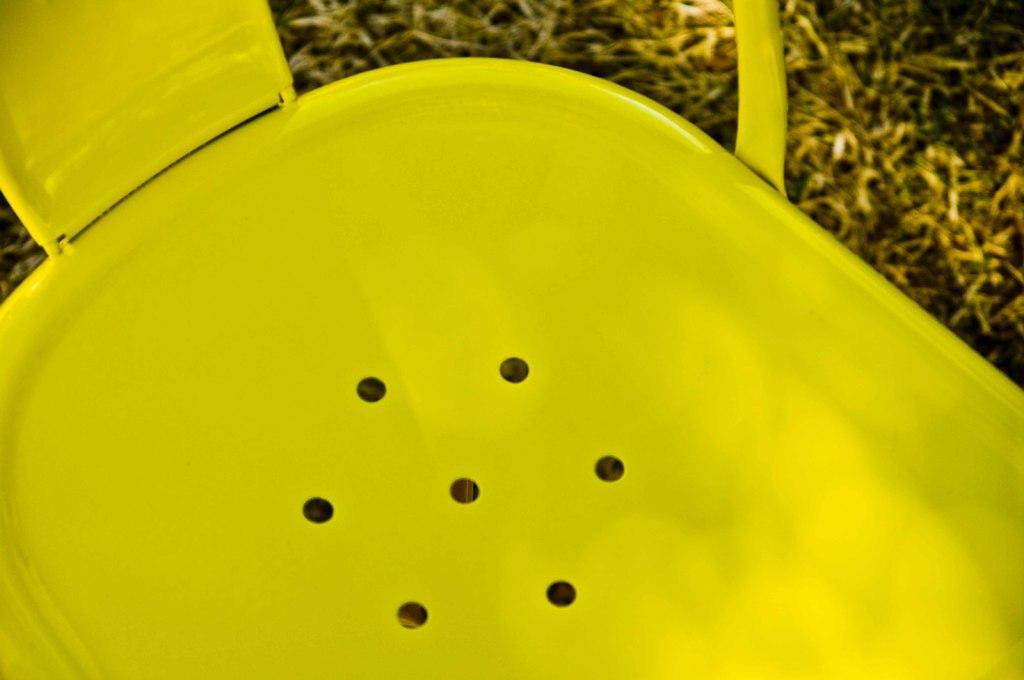What can be seen in the image? There is an object in the image. What is the color of the object? The object is yellow in color. What letter is written on the door in the image? There is no door or letter present in the image; it only contains a yellow object. What was the argument about in the image? There is no argument or people present in the image; it only contains a yellow object. 